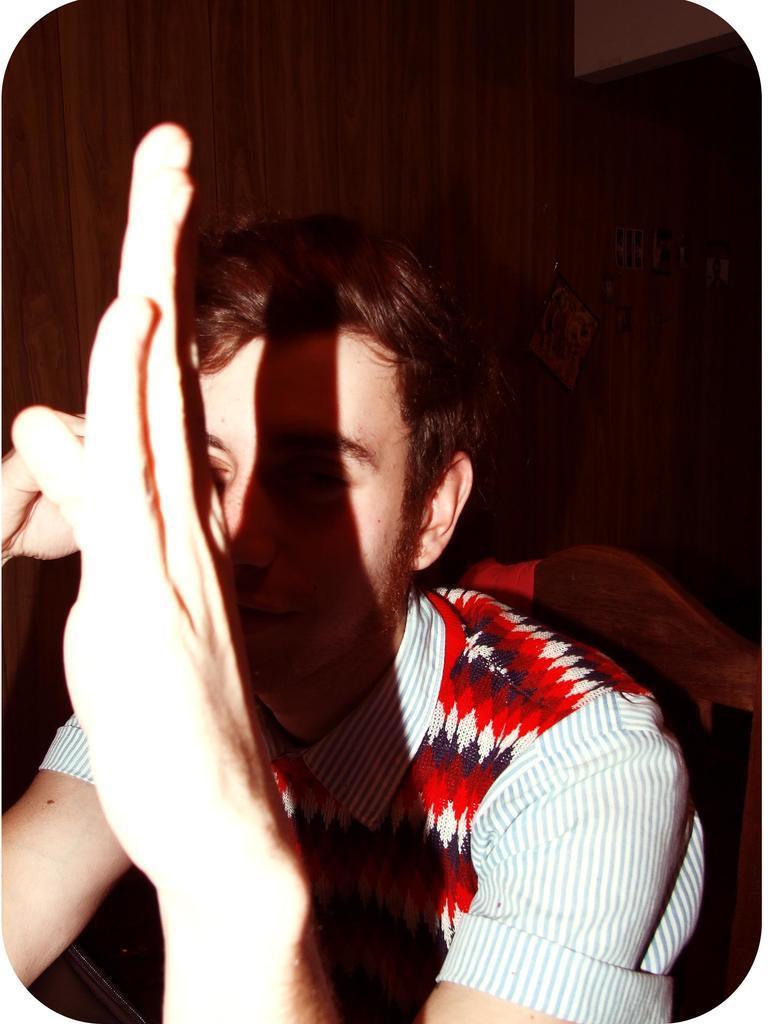Could you give a brief overview of what you see in this image? In this image we can see the person sitting on the chair and at the back we can see the wood. 